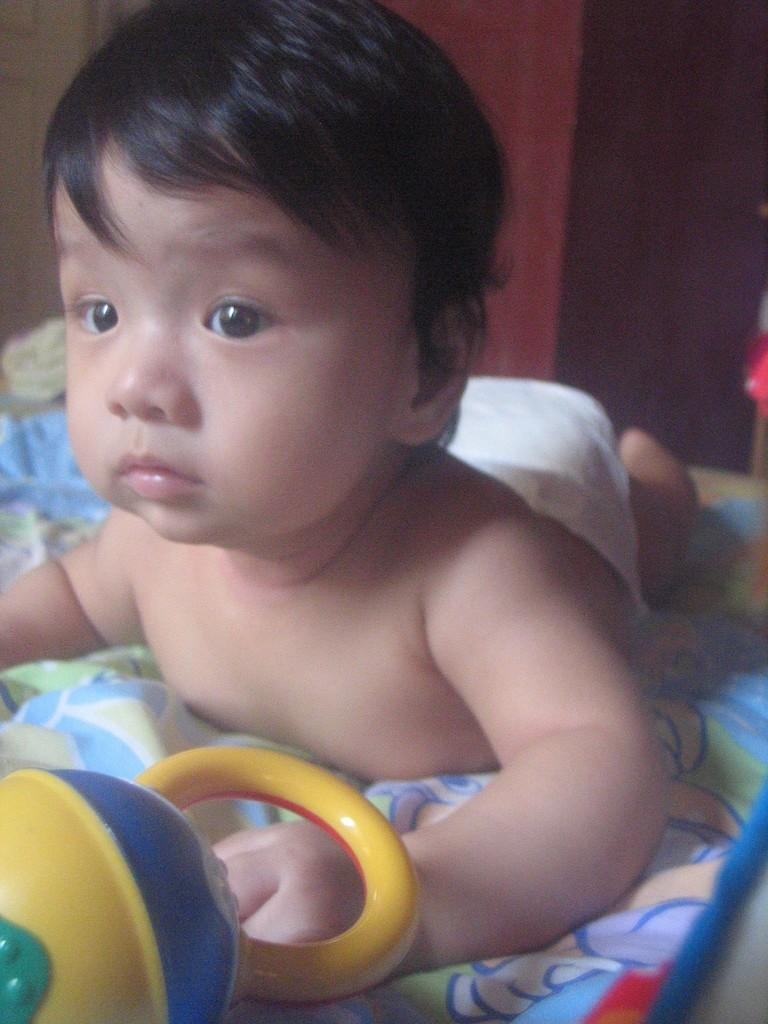What is the focus of the image? The focus of the image is a kid lying on a blanket. How is the background of the image depicted? The background portion of the picture is blurred. What else can be seen in the image besides the kid on the blanket? There is a toy visible in the image. What type of body is being requested in the image? There is no mention of a body or a request in the image; it features a kid lying on a blanket with a blurred background and a visible toy. 